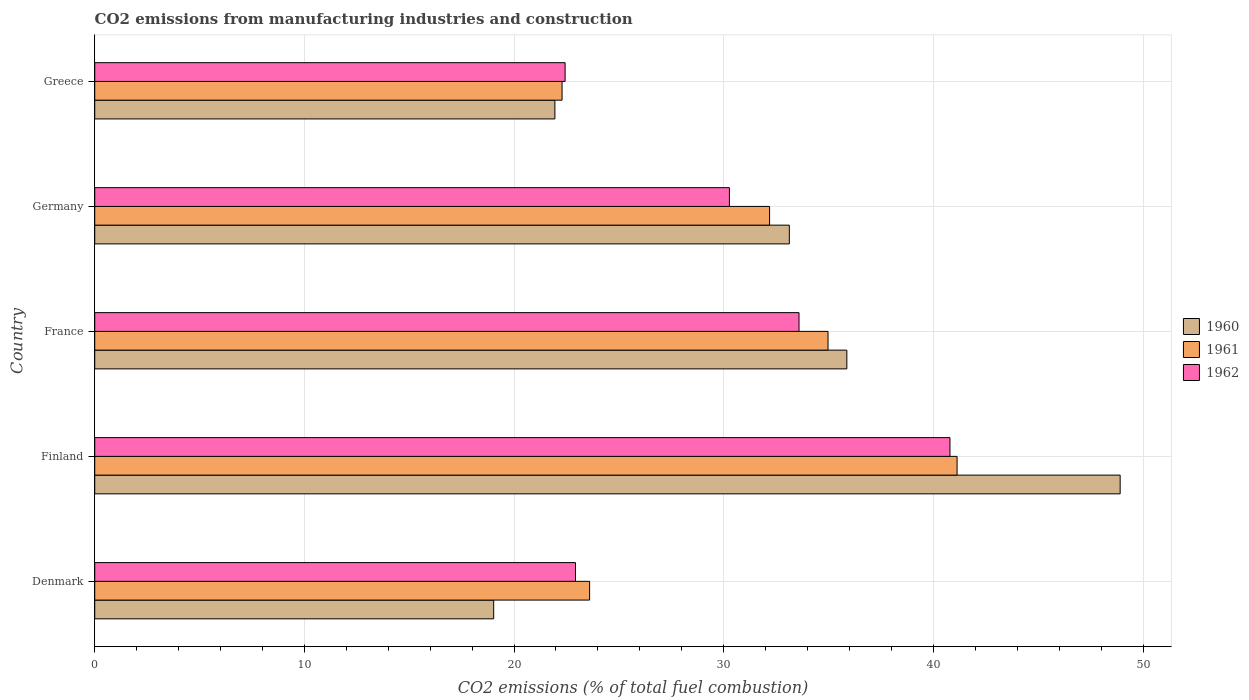Are the number of bars per tick equal to the number of legend labels?
Your answer should be very brief. Yes. How many bars are there on the 5th tick from the top?
Provide a succinct answer. 3. How many bars are there on the 5th tick from the bottom?
Your response must be concise. 3. What is the label of the 1st group of bars from the top?
Offer a terse response. Greece. In how many cases, is the number of bars for a given country not equal to the number of legend labels?
Your answer should be very brief. 0. What is the amount of CO2 emitted in 1961 in Denmark?
Keep it short and to the point. 23.6. Across all countries, what is the maximum amount of CO2 emitted in 1962?
Provide a succinct answer. 40.79. Across all countries, what is the minimum amount of CO2 emitted in 1961?
Your answer should be very brief. 22.29. In which country was the amount of CO2 emitted in 1962 maximum?
Your answer should be very brief. Finland. What is the total amount of CO2 emitted in 1962 in the graph?
Ensure brevity in your answer.  150.02. What is the difference between the amount of CO2 emitted in 1961 in Finland and that in Germany?
Offer a very short reply. 8.94. What is the difference between the amount of CO2 emitted in 1960 in Denmark and the amount of CO2 emitted in 1962 in Finland?
Offer a terse response. -21.76. What is the average amount of CO2 emitted in 1962 per country?
Your answer should be very brief. 30. What is the difference between the amount of CO2 emitted in 1960 and amount of CO2 emitted in 1962 in Denmark?
Give a very brief answer. -3.9. What is the ratio of the amount of CO2 emitted in 1961 in Denmark to that in Germany?
Ensure brevity in your answer.  0.73. Is the amount of CO2 emitted in 1960 in Germany less than that in Greece?
Provide a succinct answer. No. Is the difference between the amount of CO2 emitted in 1960 in Germany and Greece greater than the difference between the amount of CO2 emitted in 1962 in Germany and Greece?
Give a very brief answer. Yes. What is the difference between the highest and the second highest amount of CO2 emitted in 1962?
Provide a short and direct response. 7.2. What is the difference between the highest and the lowest amount of CO2 emitted in 1961?
Offer a very short reply. 18.84. What does the 3rd bar from the top in Greece represents?
Offer a very short reply. 1960. Is it the case that in every country, the sum of the amount of CO2 emitted in 1962 and amount of CO2 emitted in 1960 is greater than the amount of CO2 emitted in 1961?
Ensure brevity in your answer.  Yes. How many bars are there?
Offer a terse response. 15. Are all the bars in the graph horizontal?
Offer a terse response. Yes. How many countries are there in the graph?
Keep it short and to the point. 5. Does the graph contain any zero values?
Your answer should be compact. No. Where does the legend appear in the graph?
Your answer should be compact. Center right. How many legend labels are there?
Your answer should be very brief. 3. How are the legend labels stacked?
Your answer should be very brief. Vertical. What is the title of the graph?
Give a very brief answer. CO2 emissions from manufacturing industries and construction. Does "1966" appear as one of the legend labels in the graph?
Your answer should be compact. No. What is the label or title of the X-axis?
Offer a terse response. CO2 emissions (% of total fuel combustion). What is the CO2 emissions (% of total fuel combustion) in 1960 in Denmark?
Keep it short and to the point. 19.03. What is the CO2 emissions (% of total fuel combustion) in 1961 in Denmark?
Ensure brevity in your answer.  23.6. What is the CO2 emissions (% of total fuel combustion) in 1962 in Denmark?
Offer a very short reply. 22.93. What is the CO2 emissions (% of total fuel combustion) in 1960 in Finland?
Provide a short and direct response. 48.91. What is the CO2 emissions (% of total fuel combustion) of 1961 in Finland?
Offer a terse response. 41.13. What is the CO2 emissions (% of total fuel combustion) in 1962 in Finland?
Your answer should be very brief. 40.79. What is the CO2 emissions (% of total fuel combustion) in 1960 in France?
Ensure brevity in your answer.  35.87. What is the CO2 emissions (% of total fuel combustion) of 1961 in France?
Your answer should be very brief. 34.98. What is the CO2 emissions (% of total fuel combustion) in 1962 in France?
Your response must be concise. 33.59. What is the CO2 emissions (% of total fuel combustion) of 1960 in Germany?
Your response must be concise. 33.13. What is the CO2 emissions (% of total fuel combustion) of 1961 in Germany?
Provide a short and direct response. 32.19. What is the CO2 emissions (% of total fuel combustion) in 1962 in Germany?
Give a very brief answer. 30.27. What is the CO2 emissions (% of total fuel combustion) of 1960 in Greece?
Your answer should be very brief. 21.95. What is the CO2 emissions (% of total fuel combustion) in 1961 in Greece?
Give a very brief answer. 22.29. What is the CO2 emissions (% of total fuel combustion) of 1962 in Greece?
Your answer should be compact. 22.44. Across all countries, what is the maximum CO2 emissions (% of total fuel combustion) of 1960?
Keep it short and to the point. 48.91. Across all countries, what is the maximum CO2 emissions (% of total fuel combustion) in 1961?
Offer a terse response. 41.13. Across all countries, what is the maximum CO2 emissions (% of total fuel combustion) in 1962?
Your answer should be compact. 40.79. Across all countries, what is the minimum CO2 emissions (% of total fuel combustion) of 1960?
Provide a succinct answer. 19.03. Across all countries, what is the minimum CO2 emissions (% of total fuel combustion) in 1961?
Your answer should be compact. 22.29. Across all countries, what is the minimum CO2 emissions (% of total fuel combustion) in 1962?
Your answer should be compact. 22.44. What is the total CO2 emissions (% of total fuel combustion) in 1960 in the graph?
Offer a very short reply. 158.89. What is the total CO2 emissions (% of total fuel combustion) in 1961 in the graph?
Offer a very short reply. 154.19. What is the total CO2 emissions (% of total fuel combustion) in 1962 in the graph?
Offer a very short reply. 150.02. What is the difference between the CO2 emissions (% of total fuel combustion) in 1960 in Denmark and that in Finland?
Your answer should be compact. -29.88. What is the difference between the CO2 emissions (% of total fuel combustion) in 1961 in Denmark and that in Finland?
Provide a short and direct response. -17.53. What is the difference between the CO2 emissions (% of total fuel combustion) in 1962 in Denmark and that in Finland?
Give a very brief answer. -17.86. What is the difference between the CO2 emissions (% of total fuel combustion) in 1960 in Denmark and that in France?
Ensure brevity in your answer.  -16.84. What is the difference between the CO2 emissions (% of total fuel combustion) in 1961 in Denmark and that in France?
Make the answer very short. -11.37. What is the difference between the CO2 emissions (% of total fuel combustion) of 1962 in Denmark and that in France?
Ensure brevity in your answer.  -10.66. What is the difference between the CO2 emissions (% of total fuel combustion) in 1960 in Denmark and that in Germany?
Offer a terse response. -14.1. What is the difference between the CO2 emissions (% of total fuel combustion) in 1961 in Denmark and that in Germany?
Keep it short and to the point. -8.58. What is the difference between the CO2 emissions (% of total fuel combustion) of 1962 in Denmark and that in Germany?
Give a very brief answer. -7.34. What is the difference between the CO2 emissions (% of total fuel combustion) of 1960 in Denmark and that in Greece?
Keep it short and to the point. -2.92. What is the difference between the CO2 emissions (% of total fuel combustion) of 1961 in Denmark and that in Greece?
Provide a succinct answer. 1.31. What is the difference between the CO2 emissions (% of total fuel combustion) in 1962 in Denmark and that in Greece?
Give a very brief answer. 0.5. What is the difference between the CO2 emissions (% of total fuel combustion) of 1960 in Finland and that in France?
Ensure brevity in your answer.  13.04. What is the difference between the CO2 emissions (% of total fuel combustion) of 1961 in Finland and that in France?
Give a very brief answer. 6.16. What is the difference between the CO2 emissions (% of total fuel combustion) of 1962 in Finland and that in France?
Your answer should be compact. 7.2. What is the difference between the CO2 emissions (% of total fuel combustion) in 1960 in Finland and that in Germany?
Give a very brief answer. 15.78. What is the difference between the CO2 emissions (% of total fuel combustion) in 1961 in Finland and that in Germany?
Offer a very short reply. 8.94. What is the difference between the CO2 emissions (% of total fuel combustion) of 1962 in Finland and that in Germany?
Keep it short and to the point. 10.52. What is the difference between the CO2 emissions (% of total fuel combustion) in 1960 in Finland and that in Greece?
Provide a short and direct response. 26.96. What is the difference between the CO2 emissions (% of total fuel combustion) of 1961 in Finland and that in Greece?
Your answer should be very brief. 18.84. What is the difference between the CO2 emissions (% of total fuel combustion) in 1962 in Finland and that in Greece?
Ensure brevity in your answer.  18.36. What is the difference between the CO2 emissions (% of total fuel combustion) in 1960 in France and that in Germany?
Your answer should be very brief. 2.74. What is the difference between the CO2 emissions (% of total fuel combustion) in 1961 in France and that in Germany?
Offer a very short reply. 2.79. What is the difference between the CO2 emissions (% of total fuel combustion) in 1962 in France and that in Germany?
Provide a short and direct response. 3.32. What is the difference between the CO2 emissions (% of total fuel combustion) of 1960 in France and that in Greece?
Give a very brief answer. 13.92. What is the difference between the CO2 emissions (% of total fuel combustion) in 1961 in France and that in Greece?
Your answer should be very brief. 12.69. What is the difference between the CO2 emissions (% of total fuel combustion) of 1962 in France and that in Greece?
Provide a short and direct response. 11.16. What is the difference between the CO2 emissions (% of total fuel combustion) of 1960 in Germany and that in Greece?
Provide a succinct answer. 11.18. What is the difference between the CO2 emissions (% of total fuel combustion) in 1961 in Germany and that in Greece?
Ensure brevity in your answer.  9.9. What is the difference between the CO2 emissions (% of total fuel combustion) of 1962 in Germany and that in Greece?
Provide a short and direct response. 7.84. What is the difference between the CO2 emissions (% of total fuel combustion) in 1960 in Denmark and the CO2 emissions (% of total fuel combustion) in 1961 in Finland?
Your response must be concise. -22.1. What is the difference between the CO2 emissions (% of total fuel combustion) in 1960 in Denmark and the CO2 emissions (% of total fuel combustion) in 1962 in Finland?
Your response must be concise. -21.76. What is the difference between the CO2 emissions (% of total fuel combustion) in 1961 in Denmark and the CO2 emissions (% of total fuel combustion) in 1962 in Finland?
Provide a succinct answer. -17.19. What is the difference between the CO2 emissions (% of total fuel combustion) of 1960 in Denmark and the CO2 emissions (% of total fuel combustion) of 1961 in France?
Provide a short and direct response. -15.95. What is the difference between the CO2 emissions (% of total fuel combustion) in 1960 in Denmark and the CO2 emissions (% of total fuel combustion) in 1962 in France?
Provide a short and direct response. -14.56. What is the difference between the CO2 emissions (% of total fuel combustion) in 1961 in Denmark and the CO2 emissions (% of total fuel combustion) in 1962 in France?
Provide a short and direct response. -9.99. What is the difference between the CO2 emissions (% of total fuel combustion) of 1960 in Denmark and the CO2 emissions (% of total fuel combustion) of 1961 in Germany?
Offer a very short reply. -13.16. What is the difference between the CO2 emissions (% of total fuel combustion) of 1960 in Denmark and the CO2 emissions (% of total fuel combustion) of 1962 in Germany?
Keep it short and to the point. -11.24. What is the difference between the CO2 emissions (% of total fuel combustion) of 1961 in Denmark and the CO2 emissions (% of total fuel combustion) of 1962 in Germany?
Offer a very short reply. -6.67. What is the difference between the CO2 emissions (% of total fuel combustion) in 1960 in Denmark and the CO2 emissions (% of total fuel combustion) in 1961 in Greece?
Provide a short and direct response. -3.26. What is the difference between the CO2 emissions (% of total fuel combustion) in 1960 in Denmark and the CO2 emissions (% of total fuel combustion) in 1962 in Greece?
Offer a terse response. -3.41. What is the difference between the CO2 emissions (% of total fuel combustion) in 1961 in Denmark and the CO2 emissions (% of total fuel combustion) in 1962 in Greece?
Provide a succinct answer. 1.17. What is the difference between the CO2 emissions (% of total fuel combustion) in 1960 in Finland and the CO2 emissions (% of total fuel combustion) in 1961 in France?
Keep it short and to the point. 13.93. What is the difference between the CO2 emissions (% of total fuel combustion) in 1960 in Finland and the CO2 emissions (% of total fuel combustion) in 1962 in France?
Provide a succinct answer. 15.32. What is the difference between the CO2 emissions (% of total fuel combustion) in 1961 in Finland and the CO2 emissions (% of total fuel combustion) in 1962 in France?
Provide a short and direct response. 7.54. What is the difference between the CO2 emissions (% of total fuel combustion) of 1960 in Finland and the CO2 emissions (% of total fuel combustion) of 1961 in Germany?
Your answer should be compact. 16.72. What is the difference between the CO2 emissions (% of total fuel combustion) of 1960 in Finland and the CO2 emissions (% of total fuel combustion) of 1962 in Germany?
Your answer should be compact. 18.64. What is the difference between the CO2 emissions (% of total fuel combustion) of 1961 in Finland and the CO2 emissions (% of total fuel combustion) of 1962 in Germany?
Your response must be concise. 10.86. What is the difference between the CO2 emissions (% of total fuel combustion) of 1960 in Finland and the CO2 emissions (% of total fuel combustion) of 1961 in Greece?
Your answer should be compact. 26.62. What is the difference between the CO2 emissions (% of total fuel combustion) in 1960 in Finland and the CO2 emissions (% of total fuel combustion) in 1962 in Greece?
Offer a very short reply. 26.47. What is the difference between the CO2 emissions (% of total fuel combustion) of 1961 in Finland and the CO2 emissions (% of total fuel combustion) of 1962 in Greece?
Provide a succinct answer. 18.7. What is the difference between the CO2 emissions (% of total fuel combustion) in 1960 in France and the CO2 emissions (% of total fuel combustion) in 1961 in Germany?
Your answer should be very brief. 3.68. What is the difference between the CO2 emissions (% of total fuel combustion) in 1960 in France and the CO2 emissions (% of total fuel combustion) in 1962 in Germany?
Your response must be concise. 5.6. What is the difference between the CO2 emissions (% of total fuel combustion) of 1961 in France and the CO2 emissions (% of total fuel combustion) of 1962 in Germany?
Provide a short and direct response. 4.7. What is the difference between the CO2 emissions (% of total fuel combustion) in 1960 in France and the CO2 emissions (% of total fuel combustion) in 1961 in Greece?
Keep it short and to the point. 13.58. What is the difference between the CO2 emissions (% of total fuel combustion) of 1960 in France and the CO2 emissions (% of total fuel combustion) of 1962 in Greece?
Keep it short and to the point. 13.44. What is the difference between the CO2 emissions (% of total fuel combustion) in 1961 in France and the CO2 emissions (% of total fuel combustion) in 1962 in Greece?
Provide a succinct answer. 12.54. What is the difference between the CO2 emissions (% of total fuel combustion) in 1960 in Germany and the CO2 emissions (% of total fuel combustion) in 1961 in Greece?
Give a very brief answer. 10.84. What is the difference between the CO2 emissions (% of total fuel combustion) in 1960 in Germany and the CO2 emissions (% of total fuel combustion) in 1962 in Greece?
Your answer should be very brief. 10.69. What is the difference between the CO2 emissions (% of total fuel combustion) of 1961 in Germany and the CO2 emissions (% of total fuel combustion) of 1962 in Greece?
Provide a succinct answer. 9.75. What is the average CO2 emissions (% of total fuel combustion) of 1960 per country?
Provide a short and direct response. 31.78. What is the average CO2 emissions (% of total fuel combustion) of 1961 per country?
Offer a very short reply. 30.84. What is the average CO2 emissions (% of total fuel combustion) in 1962 per country?
Keep it short and to the point. 30. What is the difference between the CO2 emissions (% of total fuel combustion) in 1960 and CO2 emissions (% of total fuel combustion) in 1961 in Denmark?
Ensure brevity in your answer.  -4.57. What is the difference between the CO2 emissions (% of total fuel combustion) of 1960 and CO2 emissions (% of total fuel combustion) of 1962 in Denmark?
Your answer should be very brief. -3.9. What is the difference between the CO2 emissions (% of total fuel combustion) in 1961 and CO2 emissions (% of total fuel combustion) in 1962 in Denmark?
Your answer should be compact. 0.67. What is the difference between the CO2 emissions (% of total fuel combustion) of 1960 and CO2 emissions (% of total fuel combustion) of 1961 in Finland?
Keep it short and to the point. 7.78. What is the difference between the CO2 emissions (% of total fuel combustion) of 1960 and CO2 emissions (% of total fuel combustion) of 1962 in Finland?
Ensure brevity in your answer.  8.12. What is the difference between the CO2 emissions (% of total fuel combustion) of 1961 and CO2 emissions (% of total fuel combustion) of 1962 in Finland?
Your answer should be very brief. 0.34. What is the difference between the CO2 emissions (% of total fuel combustion) in 1960 and CO2 emissions (% of total fuel combustion) in 1961 in France?
Your answer should be compact. 0.9. What is the difference between the CO2 emissions (% of total fuel combustion) of 1960 and CO2 emissions (% of total fuel combustion) of 1962 in France?
Keep it short and to the point. 2.28. What is the difference between the CO2 emissions (% of total fuel combustion) of 1961 and CO2 emissions (% of total fuel combustion) of 1962 in France?
Offer a terse response. 1.38. What is the difference between the CO2 emissions (% of total fuel combustion) of 1960 and CO2 emissions (% of total fuel combustion) of 1961 in Germany?
Give a very brief answer. 0.94. What is the difference between the CO2 emissions (% of total fuel combustion) of 1960 and CO2 emissions (% of total fuel combustion) of 1962 in Germany?
Offer a terse response. 2.86. What is the difference between the CO2 emissions (% of total fuel combustion) of 1961 and CO2 emissions (% of total fuel combustion) of 1962 in Germany?
Offer a very short reply. 1.92. What is the difference between the CO2 emissions (% of total fuel combustion) of 1960 and CO2 emissions (% of total fuel combustion) of 1961 in Greece?
Your response must be concise. -0.34. What is the difference between the CO2 emissions (% of total fuel combustion) of 1960 and CO2 emissions (% of total fuel combustion) of 1962 in Greece?
Make the answer very short. -0.49. What is the difference between the CO2 emissions (% of total fuel combustion) in 1961 and CO2 emissions (% of total fuel combustion) in 1962 in Greece?
Offer a very short reply. -0.15. What is the ratio of the CO2 emissions (% of total fuel combustion) of 1960 in Denmark to that in Finland?
Provide a short and direct response. 0.39. What is the ratio of the CO2 emissions (% of total fuel combustion) of 1961 in Denmark to that in Finland?
Provide a short and direct response. 0.57. What is the ratio of the CO2 emissions (% of total fuel combustion) in 1962 in Denmark to that in Finland?
Ensure brevity in your answer.  0.56. What is the ratio of the CO2 emissions (% of total fuel combustion) of 1960 in Denmark to that in France?
Offer a very short reply. 0.53. What is the ratio of the CO2 emissions (% of total fuel combustion) in 1961 in Denmark to that in France?
Make the answer very short. 0.67. What is the ratio of the CO2 emissions (% of total fuel combustion) of 1962 in Denmark to that in France?
Provide a succinct answer. 0.68. What is the ratio of the CO2 emissions (% of total fuel combustion) of 1960 in Denmark to that in Germany?
Provide a succinct answer. 0.57. What is the ratio of the CO2 emissions (% of total fuel combustion) in 1961 in Denmark to that in Germany?
Provide a short and direct response. 0.73. What is the ratio of the CO2 emissions (% of total fuel combustion) in 1962 in Denmark to that in Germany?
Keep it short and to the point. 0.76. What is the ratio of the CO2 emissions (% of total fuel combustion) of 1960 in Denmark to that in Greece?
Keep it short and to the point. 0.87. What is the ratio of the CO2 emissions (% of total fuel combustion) of 1961 in Denmark to that in Greece?
Ensure brevity in your answer.  1.06. What is the ratio of the CO2 emissions (% of total fuel combustion) of 1962 in Denmark to that in Greece?
Keep it short and to the point. 1.02. What is the ratio of the CO2 emissions (% of total fuel combustion) of 1960 in Finland to that in France?
Ensure brevity in your answer.  1.36. What is the ratio of the CO2 emissions (% of total fuel combustion) in 1961 in Finland to that in France?
Offer a terse response. 1.18. What is the ratio of the CO2 emissions (% of total fuel combustion) in 1962 in Finland to that in France?
Make the answer very short. 1.21. What is the ratio of the CO2 emissions (% of total fuel combustion) of 1960 in Finland to that in Germany?
Offer a very short reply. 1.48. What is the ratio of the CO2 emissions (% of total fuel combustion) in 1961 in Finland to that in Germany?
Offer a very short reply. 1.28. What is the ratio of the CO2 emissions (% of total fuel combustion) in 1962 in Finland to that in Germany?
Provide a short and direct response. 1.35. What is the ratio of the CO2 emissions (% of total fuel combustion) in 1960 in Finland to that in Greece?
Offer a very short reply. 2.23. What is the ratio of the CO2 emissions (% of total fuel combustion) in 1961 in Finland to that in Greece?
Your response must be concise. 1.85. What is the ratio of the CO2 emissions (% of total fuel combustion) in 1962 in Finland to that in Greece?
Make the answer very short. 1.82. What is the ratio of the CO2 emissions (% of total fuel combustion) of 1960 in France to that in Germany?
Ensure brevity in your answer.  1.08. What is the ratio of the CO2 emissions (% of total fuel combustion) of 1961 in France to that in Germany?
Offer a very short reply. 1.09. What is the ratio of the CO2 emissions (% of total fuel combustion) in 1962 in France to that in Germany?
Your answer should be very brief. 1.11. What is the ratio of the CO2 emissions (% of total fuel combustion) in 1960 in France to that in Greece?
Provide a succinct answer. 1.63. What is the ratio of the CO2 emissions (% of total fuel combustion) in 1961 in France to that in Greece?
Provide a short and direct response. 1.57. What is the ratio of the CO2 emissions (% of total fuel combustion) of 1962 in France to that in Greece?
Make the answer very short. 1.5. What is the ratio of the CO2 emissions (% of total fuel combustion) in 1960 in Germany to that in Greece?
Give a very brief answer. 1.51. What is the ratio of the CO2 emissions (% of total fuel combustion) of 1961 in Germany to that in Greece?
Give a very brief answer. 1.44. What is the ratio of the CO2 emissions (% of total fuel combustion) of 1962 in Germany to that in Greece?
Your answer should be compact. 1.35. What is the difference between the highest and the second highest CO2 emissions (% of total fuel combustion) of 1960?
Your answer should be very brief. 13.04. What is the difference between the highest and the second highest CO2 emissions (% of total fuel combustion) of 1961?
Offer a very short reply. 6.16. What is the difference between the highest and the second highest CO2 emissions (% of total fuel combustion) in 1962?
Provide a short and direct response. 7.2. What is the difference between the highest and the lowest CO2 emissions (% of total fuel combustion) in 1960?
Provide a short and direct response. 29.88. What is the difference between the highest and the lowest CO2 emissions (% of total fuel combustion) of 1961?
Your response must be concise. 18.84. What is the difference between the highest and the lowest CO2 emissions (% of total fuel combustion) of 1962?
Ensure brevity in your answer.  18.36. 